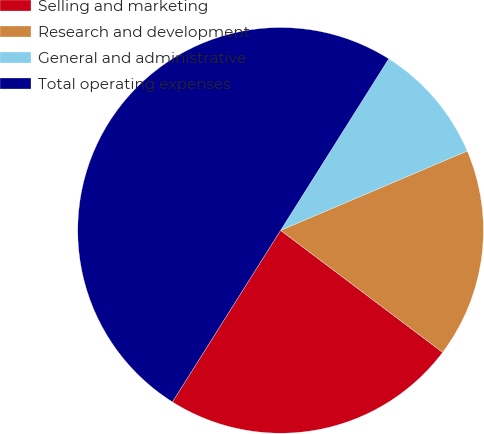<chart> <loc_0><loc_0><loc_500><loc_500><pie_chart><fcel>Selling and marketing<fcel>Research and development<fcel>General and administrative<fcel>Total operating expenses<nl><fcel>23.68%<fcel>16.67%<fcel>9.65%<fcel>50.0%<nl></chart> 